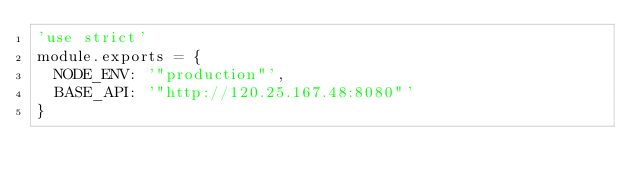Convert code to text. <code><loc_0><loc_0><loc_500><loc_500><_JavaScript_>'use strict'
module.exports = {
  NODE_ENV: '"production"',
  BASE_API: '"http://120.25.167.48:8080"'
}
</code> 